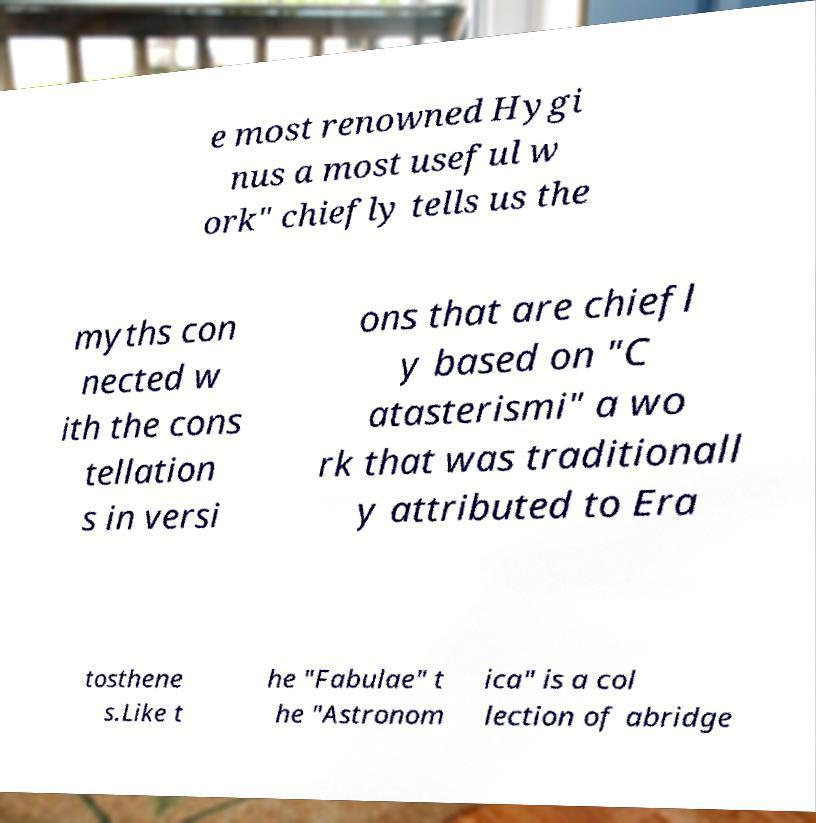Could you assist in decoding the text presented in this image and type it out clearly? e most renowned Hygi nus a most useful w ork" chiefly tells us the myths con nected w ith the cons tellation s in versi ons that are chiefl y based on "C atasterismi" a wo rk that was traditionall y attributed to Era tosthene s.Like t he "Fabulae" t he "Astronom ica" is a col lection of abridge 